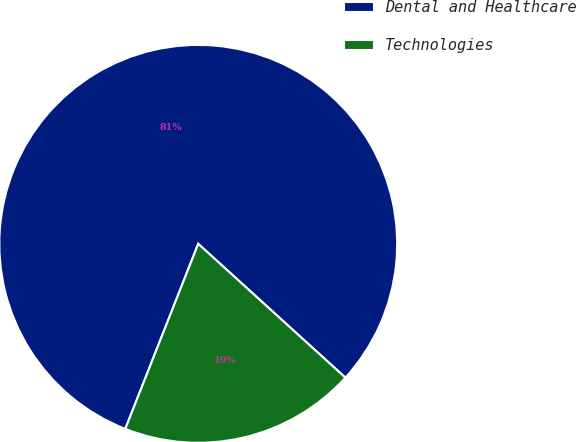Convert chart to OTSL. <chart><loc_0><loc_0><loc_500><loc_500><pie_chart><fcel>Dental and Healthcare<fcel>Technologies<nl><fcel>80.77%<fcel>19.23%<nl></chart> 